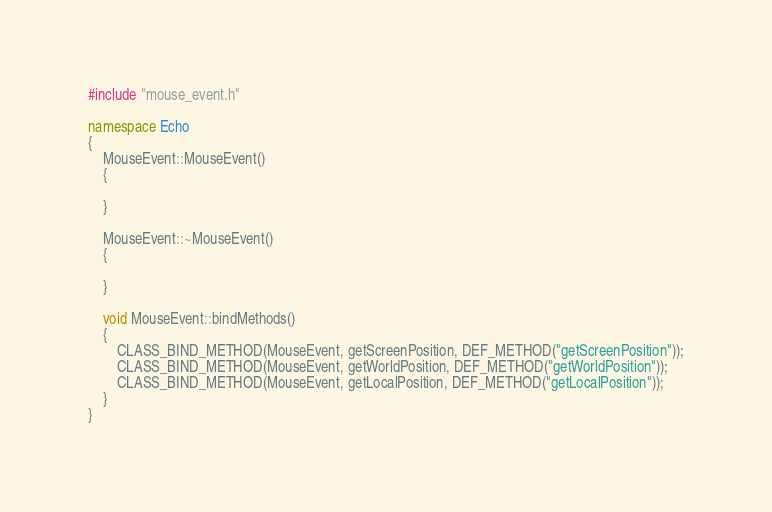Convert code to text. <code><loc_0><loc_0><loc_500><loc_500><_C++_>#include "mouse_event.h"

namespace Echo
{
	MouseEvent::MouseEvent()
	{

	}

	MouseEvent::~MouseEvent()
	{

	}

	void MouseEvent::bindMethods()
	{
		CLASS_BIND_METHOD(MouseEvent, getScreenPosition, DEF_METHOD("getScreenPosition"));
		CLASS_BIND_METHOD(MouseEvent, getWorldPosition, DEF_METHOD("getWorldPosition"));
		CLASS_BIND_METHOD(MouseEvent, getLocalPosition, DEF_METHOD("getLocalPosition"));
	}
}</code> 